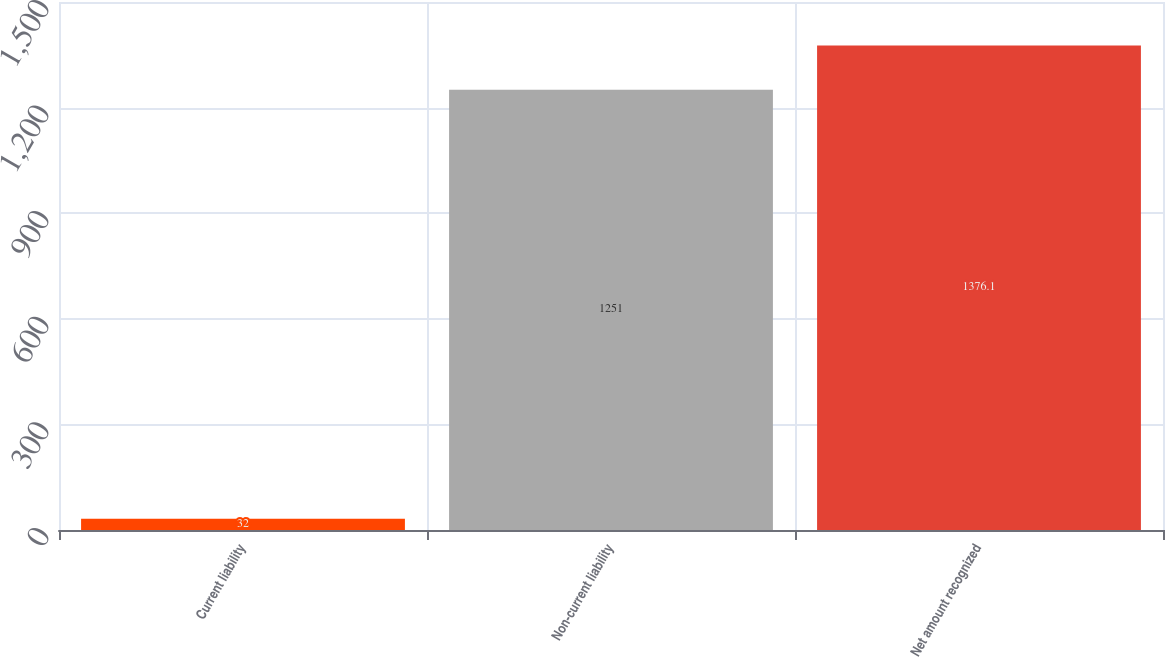Convert chart. <chart><loc_0><loc_0><loc_500><loc_500><bar_chart><fcel>Current liability<fcel>Non-current liability<fcel>Net amount recognized<nl><fcel>32<fcel>1251<fcel>1376.1<nl></chart> 